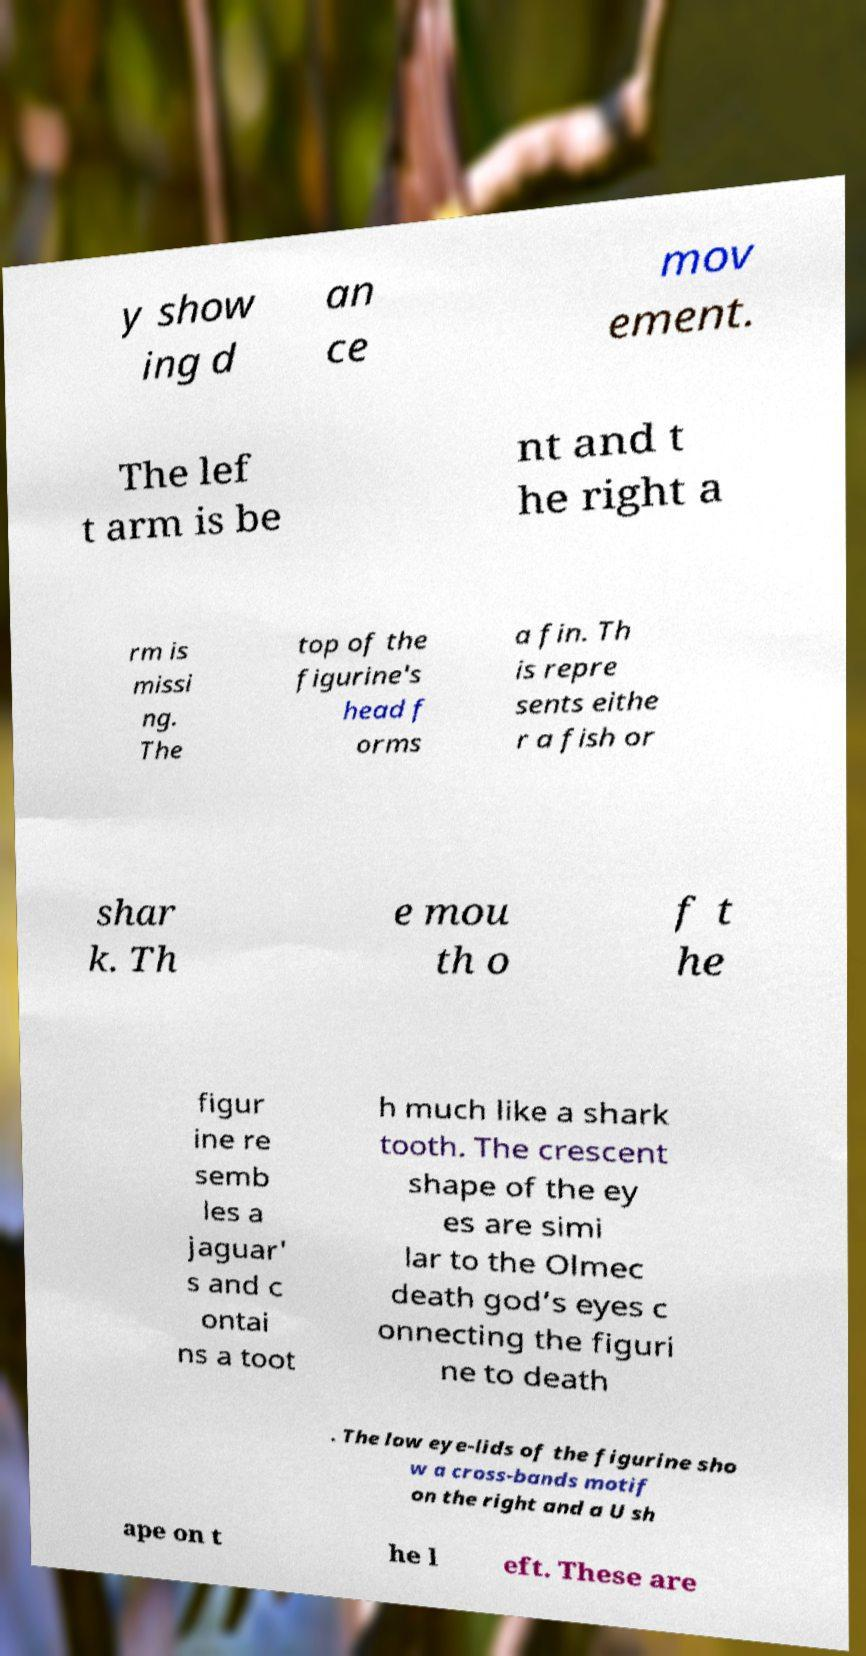Could you assist in decoding the text presented in this image and type it out clearly? y show ing d an ce mov ement. The lef t arm is be nt and t he right a rm is missi ng. The top of the figurine's head f orms a fin. Th is repre sents eithe r a fish or shar k. Th e mou th o f t he figur ine re semb les a jaguar' s and c ontai ns a toot h much like a shark tooth. The crescent shape of the ey es are simi lar to the Olmec death god’s eyes c onnecting the figuri ne to death . The low eye-lids of the figurine sho w a cross-bands motif on the right and a U sh ape on t he l eft. These are 